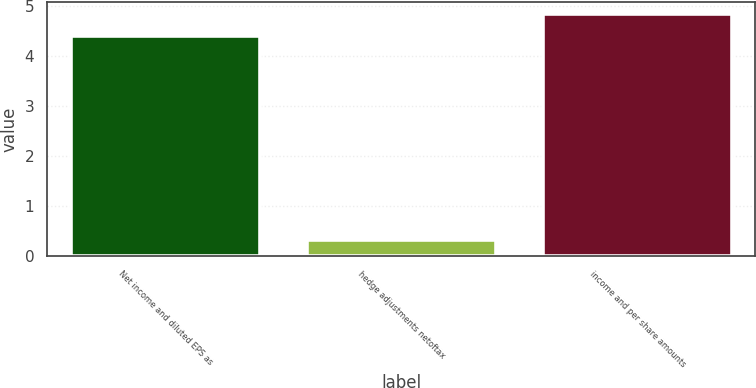<chart> <loc_0><loc_0><loc_500><loc_500><bar_chart><fcel>Net income and diluted EPS as<fcel>hedge adjustments netoftax<fcel>income and per share amounts<nl><fcel>4.4<fcel>0.33<fcel>4.84<nl></chart> 